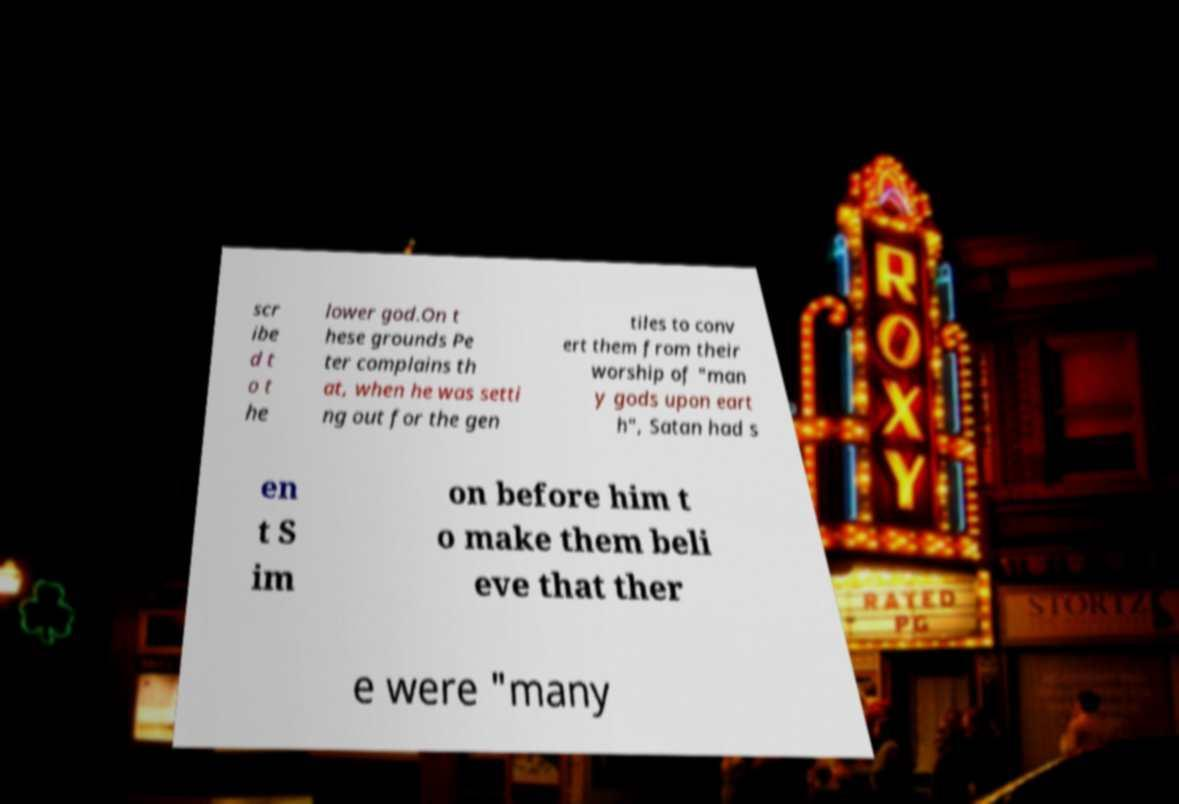Please identify and transcribe the text found in this image. scr ibe d t o t he lower god.On t hese grounds Pe ter complains th at, when he was setti ng out for the gen tiles to conv ert them from their worship of "man y gods upon eart h", Satan had s en t S im on before him t o make them beli eve that ther e were "many 